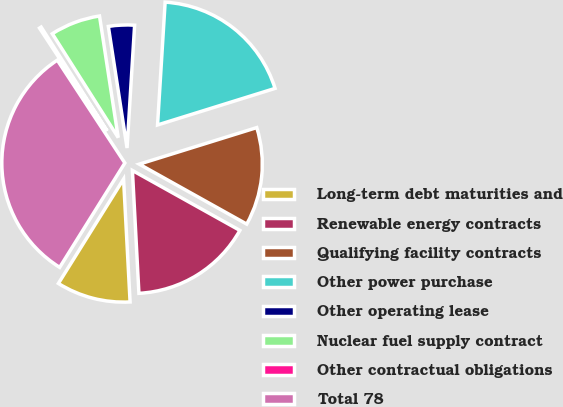Convert chart to OTSL. <chart><loc_0><loc_0><loc_500><loc_500><pie_chart><fcel>Long-term debt maturities and<fcel>Renewable energy contracts<fcel>Qualifying facility contracts<fcel>Other power purchase<fcel>Other operating lease<fcel>Nuclear fuel supply contract<fcel>Other contractual obligations<fcel>Total 78<nl><fcel>9.73%<fcel>16.06%<fcel>12.9%<fcel>19.22%<fcel>3.41%<fcel>6.57%<fcel>0.25%<fcel>31.87%<nl></chart> 